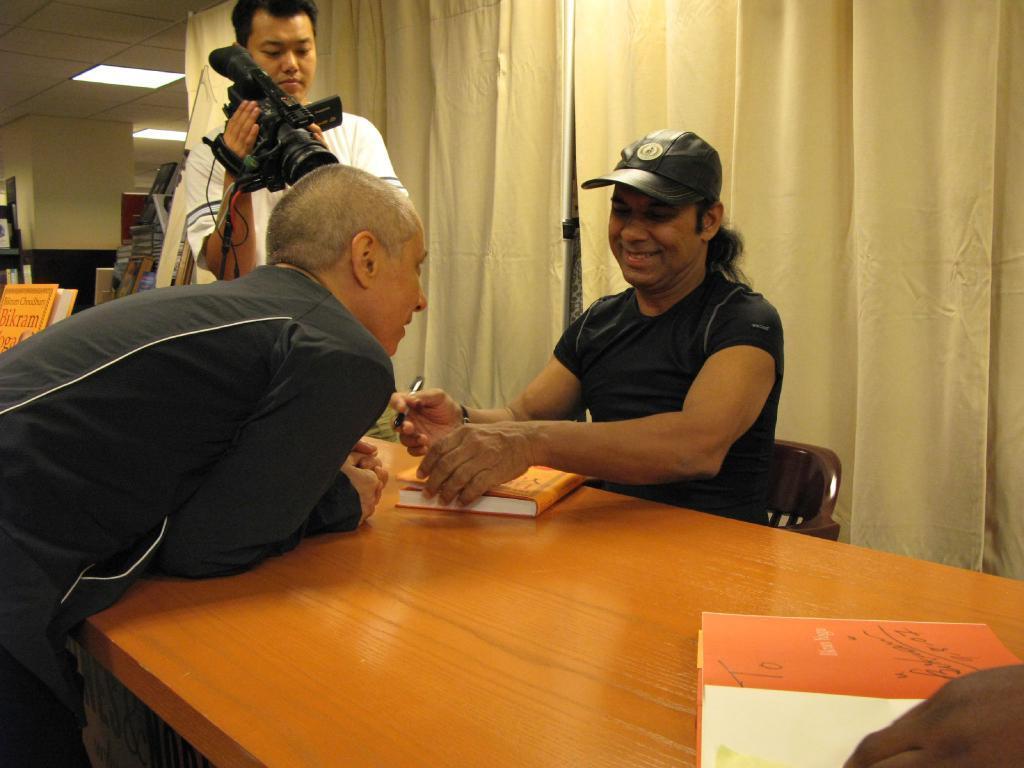Please provide a concise description of this image. This picture is clicked inside the room. There are three people in this picture. Man sitting on chair wearing black t-shirt and black cap is holding pen in his hands and he is laughing. In front of him, the man in black jacket is looking the man on the opposite side and he is smiling. Behind them, we see men in white t-shirt is holding video cam camera in his hands and he is taking video in it. In front of them, we see a table on which book and paper are placed. Behind them, we see curtain which is white in color and on the left corner of the picture, we see a pillar. 